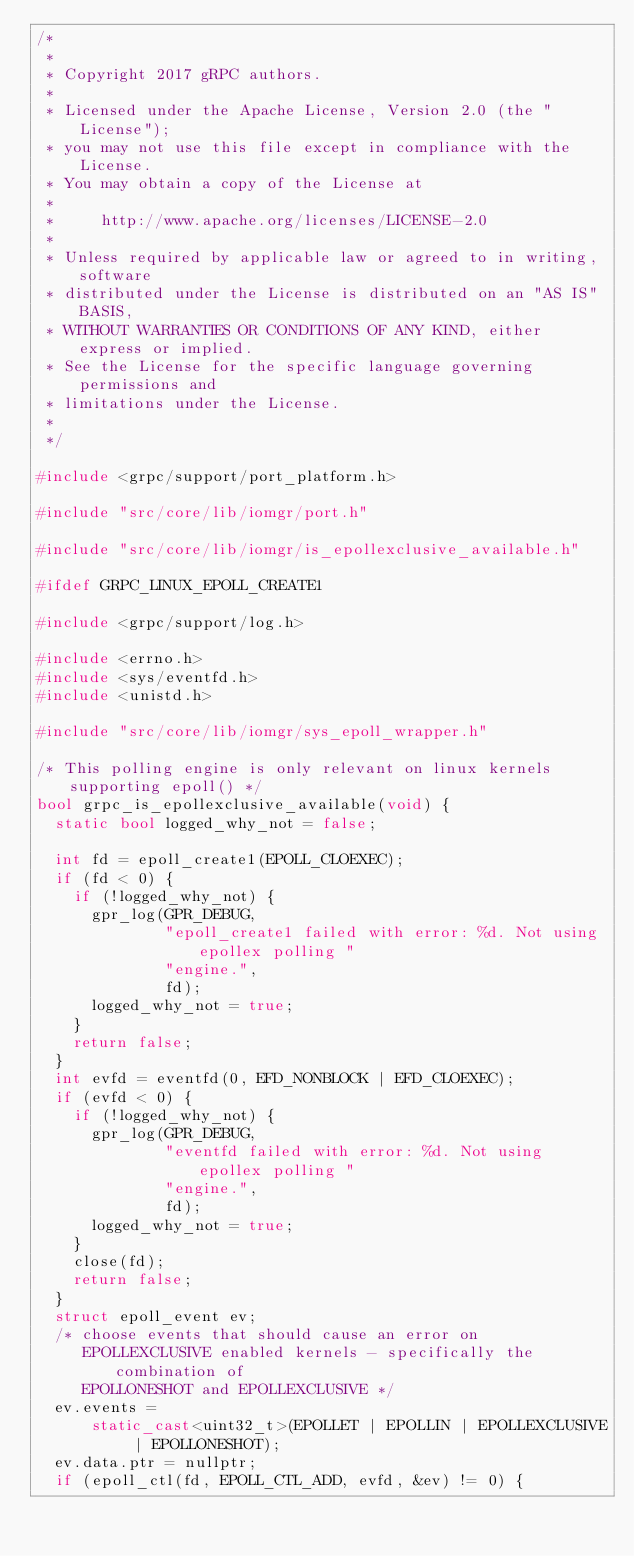Convert code to text. <code><loc_0><loc_0><loc_500><loc_500><_C++_>/*
 *
 * Copyright 2017 gRPC authors.
 *
 * Licensed under the Apache License, Version 2.0 (the "License");
 * you may not use this file except in compliance with the License.
 * You may obtain a copy of the License at
 *
 *     http://www.apache.org/licenses/LICENSE-2.0
 *
 * Unless required by applicable law or agreed to in writing, software
 * distributed under the License is distributed on an "AS IS" BASIS,
 * WITHOUT WARRANTIES OR CONDITIONS OF ANY KIND, either express or implied.
 * See the License for the specific language governing permissions and
 * limitations under the License.
 *
 */

#include <grpc/support/port_platform.h>

#include "src/core/lib/iomgr/port.h"

#include "src/core/lib/iomgr/is_epollexclusive_available.h"

#ifdef GRPC_LINUX_EPOLL_CREATE1

#include <grpc/support/log.h>

#include <errno.h>
#include <sys/eventfd.h>
#include <unistd.h>

#include "src/core/lib/iomgr/sys_epoll_wrapper.h"

/* This polling engine is only relevant on linux kernels supporting epoll() */
bool grpc_is_epollexclusive_available(void) {
  static bool logged_why_not = false;

  int fd = epoll_create1(EPOLL_CLOEXEC);
  if (fd < 0) {
    if (!logged_why_not) {
      gpr_log(GPR_DEBUG,
              "epoll_create1 failed with error: %d. Not using epollex polling "
              "engine.",
              fd);
      logged_why_not = true;
    }
    return false;
  }
  int evfd = eventfd(0, EFD_NONBLOCK | EFD_CLOEXEC);
  if (evfd < 0) {
    if (!logged_why_not) {
      gpr_log(GPR_DEBUG,
              "eventfd failed with error: %d. Not using epollex polling "
              "engine.",
              fd);
      logged_why_not = true;
    }
    close(fd);
    return false;
  }
  struct epoll_event ev;
  /* choose events that should cause an error on
     EPOLLEXCLUSIVE enabled kernels - specifically the combination of
     EPOLLONESHOT and EPOLLEXCLUSIVE */
  ev.events =
      static_cast<uint32_t>(EPOLLET | EPOLLIN | EPOLLEXCLUSIVE | EPOLLONESHOT);
  ev.data.ptr = nullptr;
  if (epoll_ctl(fd, EPOLL_CTL_ADD, evfd, &ev) != 0) {</code> 